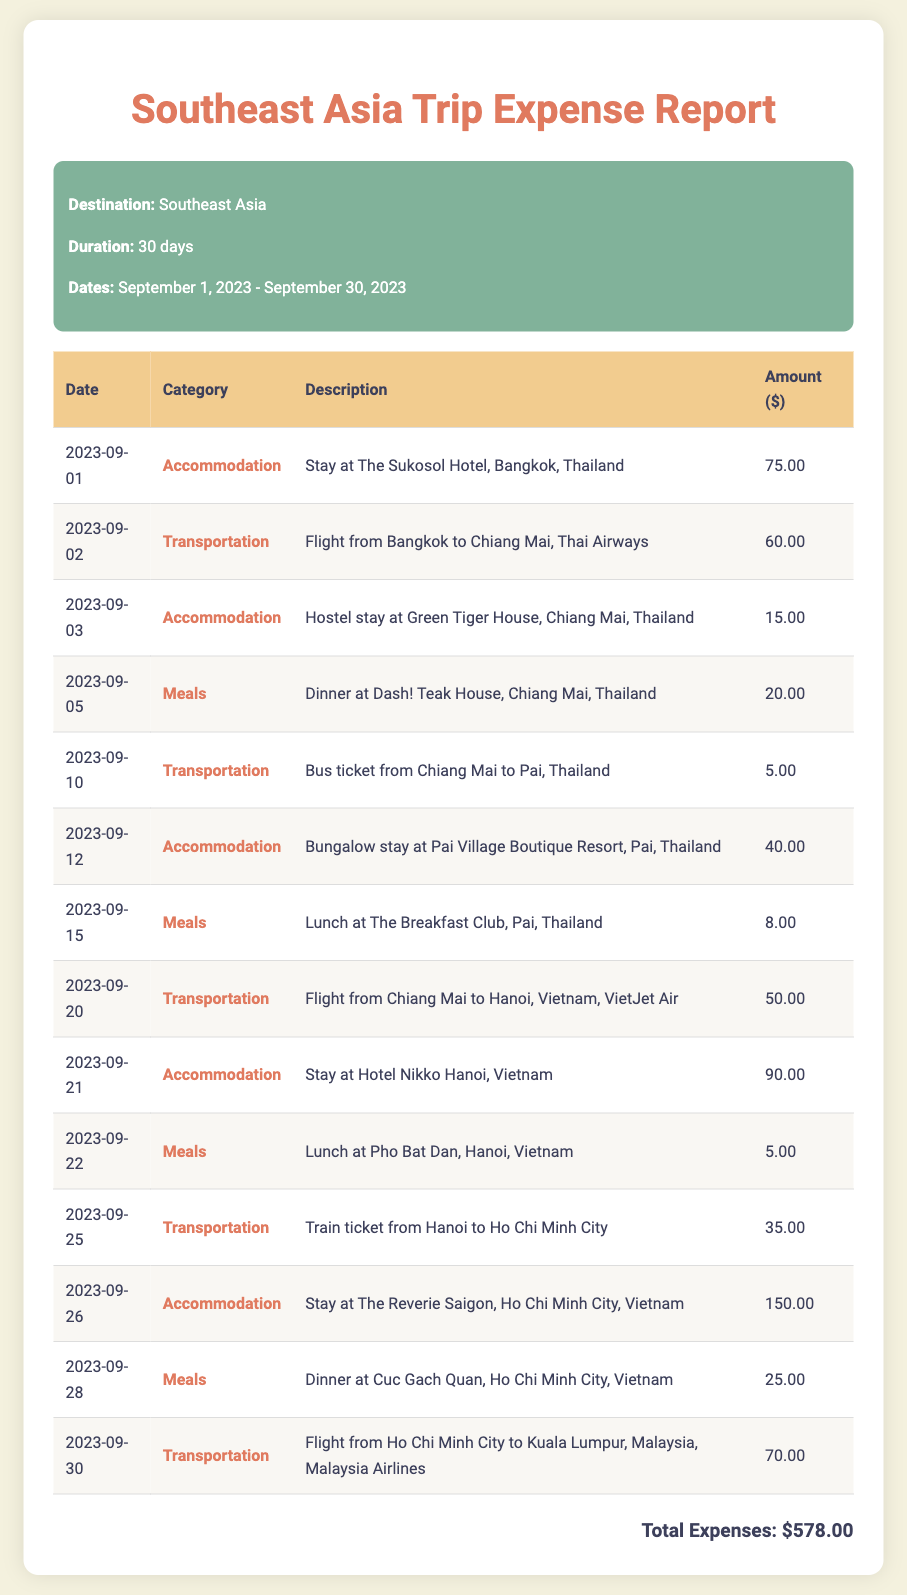What is the total amount spent on meals? The total amount spent on meals is calculated by summing the individual meal expenses listed in the report: 20 + 8 + 5 + 25 = 58.
Answer: $58.00 What was the accommodation cost in Ho Chi Minh City? The accommodation cost for the stay in Ho Chi Minh City is specifically listed as $150.00 in the document.
Answer: $150.00 How many different transportation expenses are listed? The document lists various transportation expenses, which we can count: there are 5 transportation entries.
Answer: 5 What is the cost for the flight from Chiang Mai to Hanoi? The cost for the flight from Chiang Mai to Hanoi is given as $50.00 in the report.
Answer: $50.00 What was the accommodation on September 12? The accommodation for September 12 is specified as a bungalow stay at Pai Village Boutique Resort.
Answer: Bungalow stay at Pai Village Boutique Resort Which transportation method was used on September 10? The transportation method on September 10 was a bus ticket from Chiang Mai to Pai.
Answer: Bus ticket How many days was the trip? The total duration of the trip is stated as 30 days in the trip information section.
Answer: 30 days What is the total amount spent during the trip? The total expenses calculated from the report add up to $578.00.
Answer: $578.00 What city was the first accommodation in? The first accommodation was located in Bangkok, Thailand, according to the report.
Answer: Bangkok 